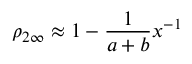<formula> <loc_0><loc_0><loc_500><loc_500>\rho _ { 2 \infty } \approx 1 - \frac { 1 } { a + b } x ^ { - 1 }</formula> 